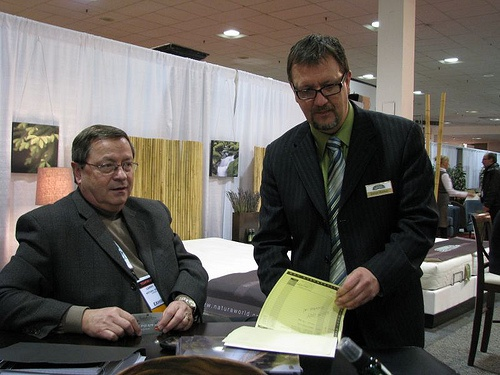Describe the objects in this image and their specific colors. I can see people in gray, black, and maroon tones, people in gray, black, and maroon tones, bed in gray, darkgray, black, and lightgray tones, bed in gray, white, and black tones, and tie in gray, black, and darkgreen tones in this image. 